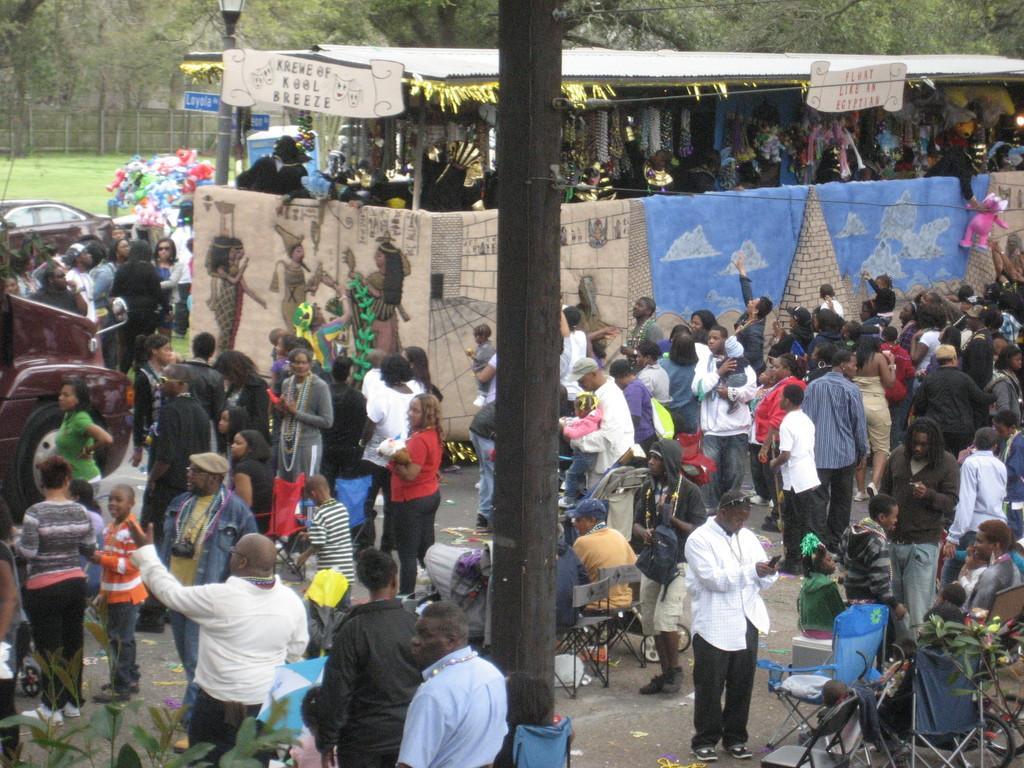Can you describe this image briefly? This picture is clicked outside on the road. In the foreground we can see the chairs and plants and there are group of people seems to be standing on the ground and there are some persons sitting on the chairs. In the center there is a pole, on the right we can see the tents. In the background there are some items placed on the ground and a car seems to be parked on the ground. On the left corner we can see the vehicle. In the background we can see the trees, lamp post, fence and the green grass. 